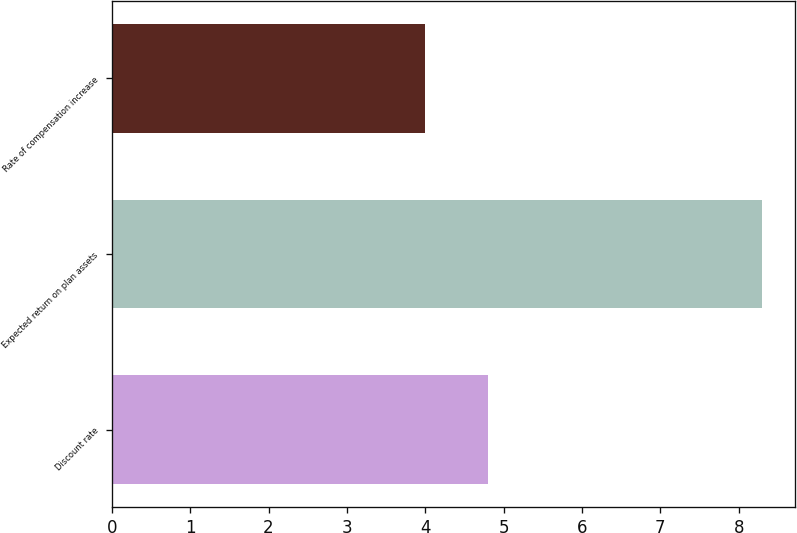Convert chart. <chart><loc_0><loc_0><loc_500><loc_500><bar_chart><fcel>Discount rate<fcel>Expected return on plan assets<fcel>Rate of compensation increase<nl><fcel>4.8<fcel>8.3<fcel>4<nl></chart> 